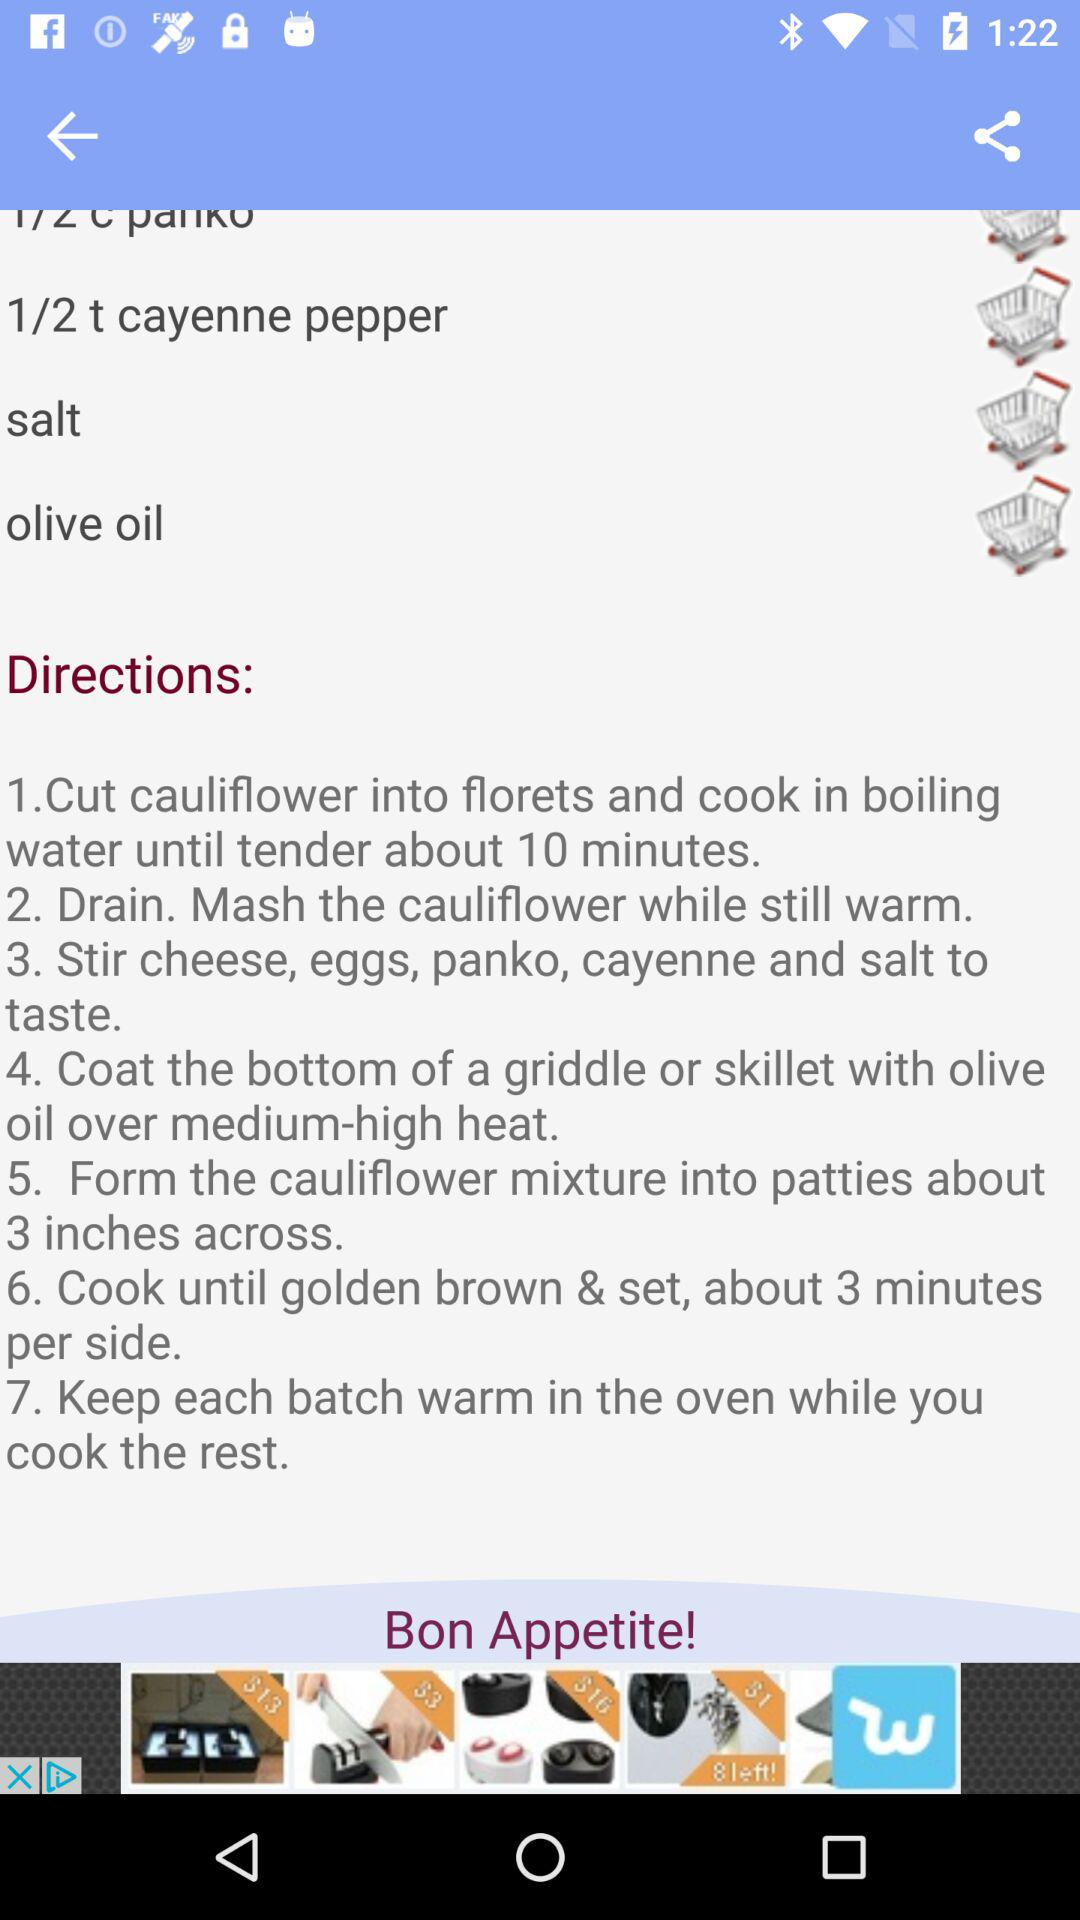How many steps are in the recipe?
Answer the question using a single word or phrase. 7 